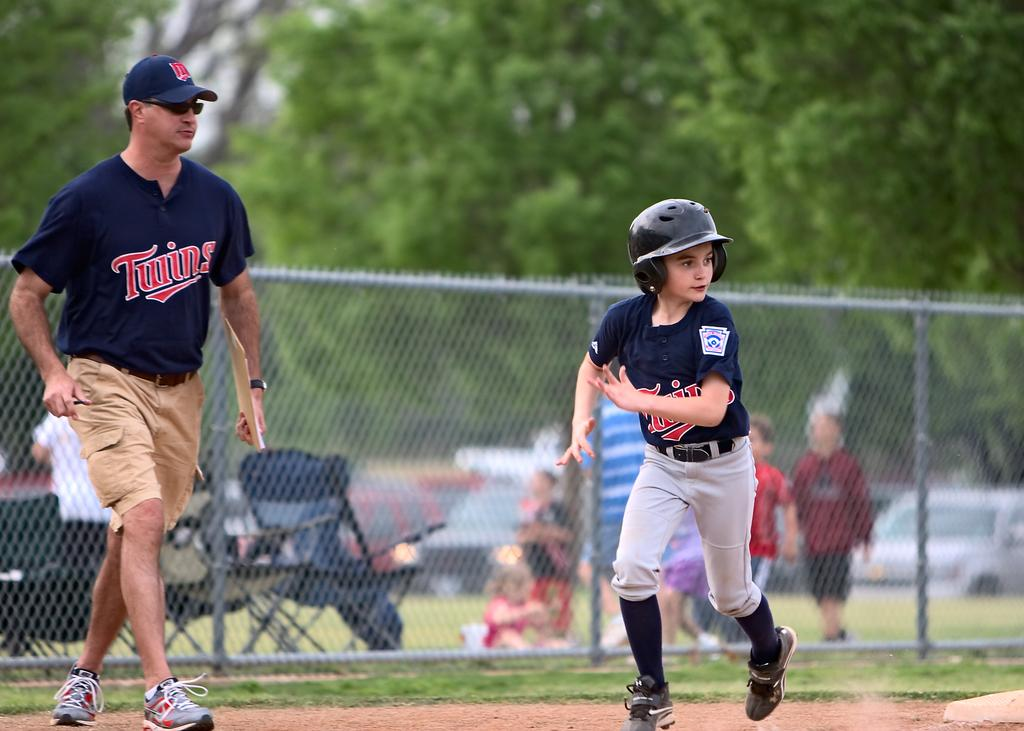<image>
Provide a brief description of the given image. Someone from the Twins is running the bases. 